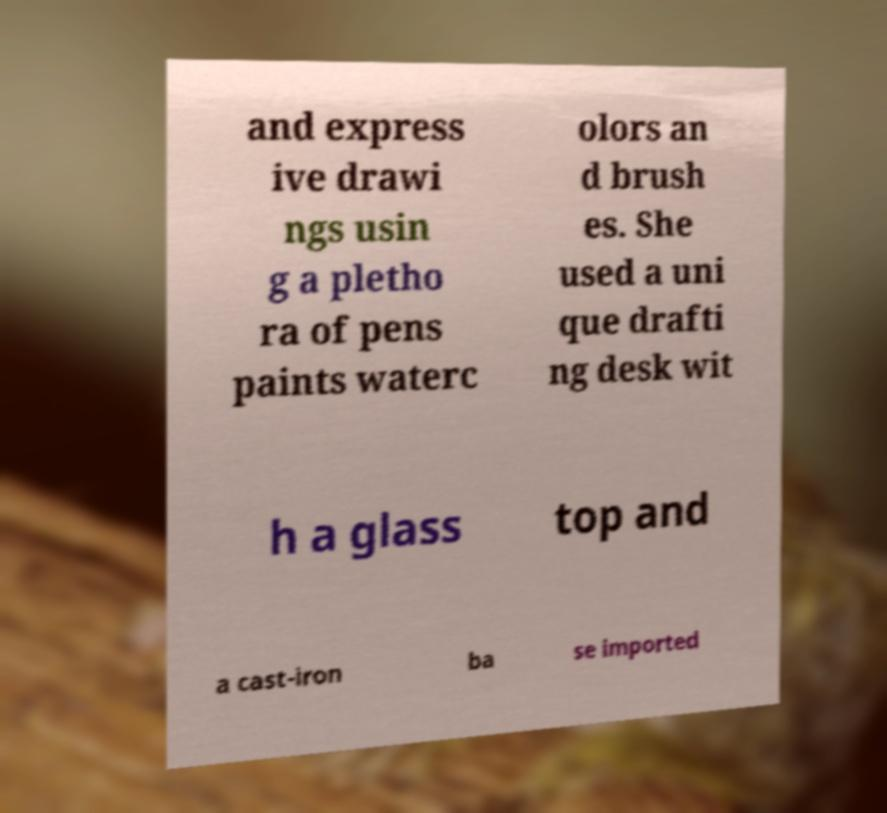There's text embedded in this image that I need extracted. Can you transcribe it verbatim? and express ive drawi ngs usin g a pletho ra of pens paints waterc olors an d brush es. She used a uni que drafti ng desk wit h a glass top and a cast-iron ba se imported 